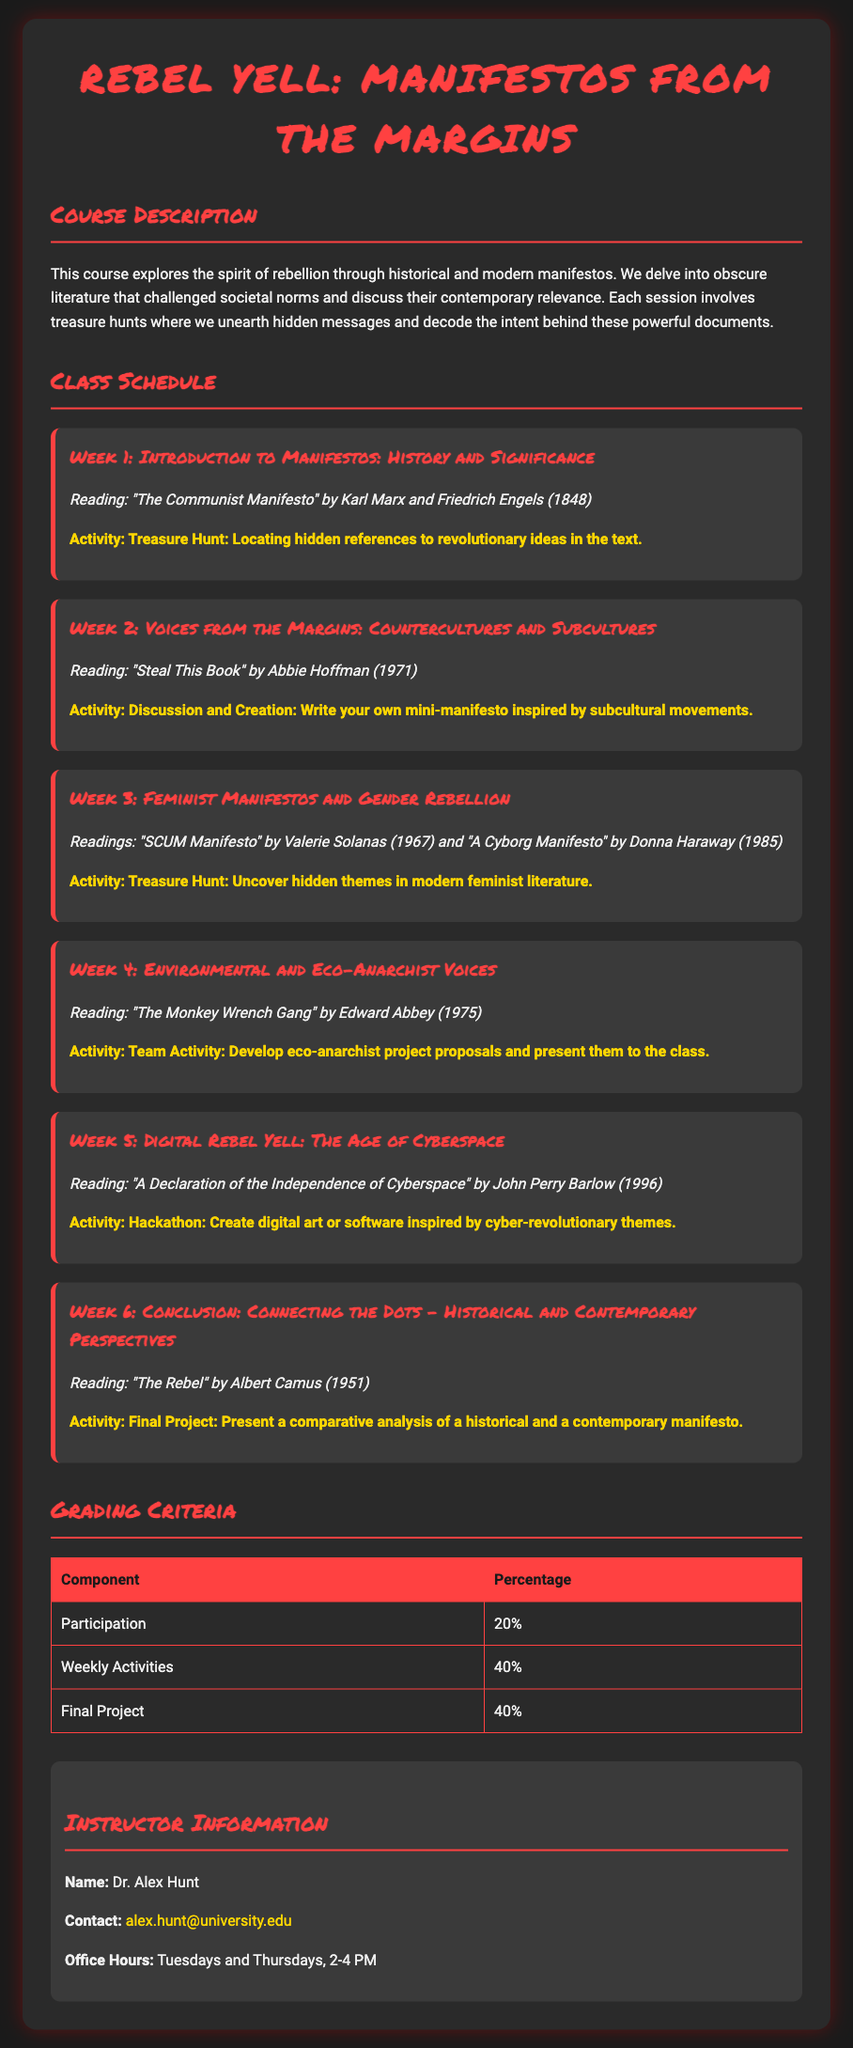What is the title of the course? The title of the course is prominently displayed at the top of the document, introducing the main theme.
Answer: Rebel Yell: Manifestos from the Margins Who is the instructor? The instructor’s name is listed under the instructor information section of the syllabus.
Answer: Dr. Alex Hunt What is the reading for Week 3? The reading assigned for Week 3 is mentioned in the context of feminist manifestos.
Answer: SCUM Manifesto and A Cyborg Manifesto How many weeks are in the class schedule? The number of weeks can be counted from the detailed weekly breakdown provided in the schedule.
Answer: 6 What percentage of the grade comes from participation? The percentage for participation is specified in the grading criteria table.
Answer: 20% What type of activity is scheduled for Week 5? The type of activity for Week 5 is described in the weekly activities section related to cyberspace.
Answer: Hackathon Which reading was assigned for the final week? The final week’s reading is indicated in the conclusion section of the syllabus.
Answer: The Rebel What is the activity for Week 2? The specific activity for Week 2 is given for the corresponding reading in the syllabus.
Answer: Discussion and Creation 